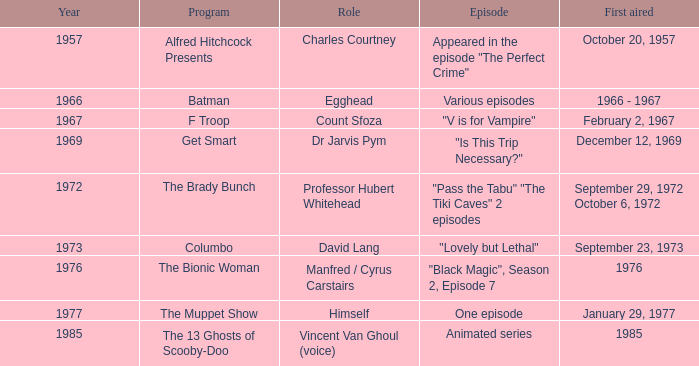What's the part of batman? Various episodes. 